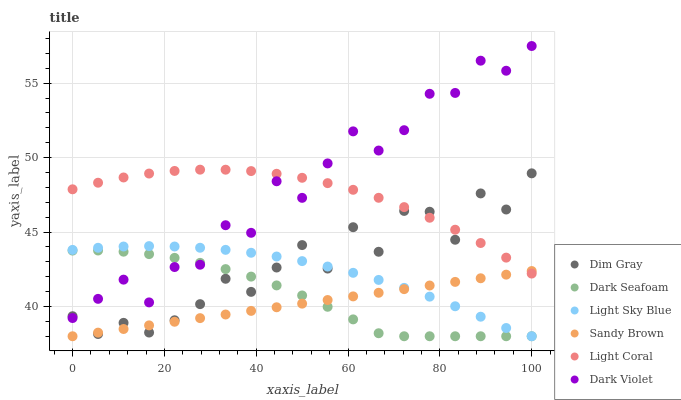Does Sandy Brown have the minimum area under the curve?
Answer yes or no. Yes. Does Dark Violet have the maximum area under the curve?
Answer yes or no. Yes. Does Light Coral have the minimum area under the curve?
Answer yes or no. No. Does Light Coral have the maximum area under the curve?
Answer yes or no. No. Is Sandy Brown the smoothest?
Answer yes or no. Yes. Is Dim Gray the roughest?
Answer yes or no. Yes. Is Dark Violet the smoothest?
Answer yes or no. No. Is Dark Violet the roughest?
Answer yes or no. No. Does Dark Seafoam have the lowest value?
Answer yes or no. Yes. Does Dark Violet have the lowest value?
Answer yes or no. No. Does Dark Violet have the highest value?
Answer yes or no. Yes. Does Light Coral have the highest value?
Answer yes or no. No. Is Light Sky Blue less than Light Coral?
Answer yes or no. Yes. Is Dark Violet greater than Sandy Brown?
Answer yes or no. Yes. Does Dark Seafoam intersect Sandy Brown?
Answer yes or no. Yes. Is Dark Seafoam less than Sandy Brown?
Answer yes or no. No. Is Dark Seafoam greater than Sandy Brown?
Answer yes or no. No. Does Light Sky Blue intersect Light Coral?
Answer yes or no. No. 